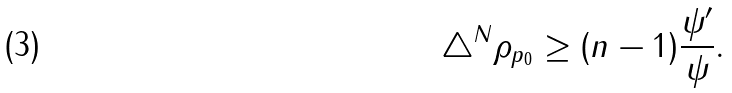<formula> <loc_0><loc_0><loc_500><loc_500>\triangle ^ { N } \rho _ { p _ { 0 } } \geq ( n - 1 ) \frac { \psi ^ { \prime } } \psi .</formula> 